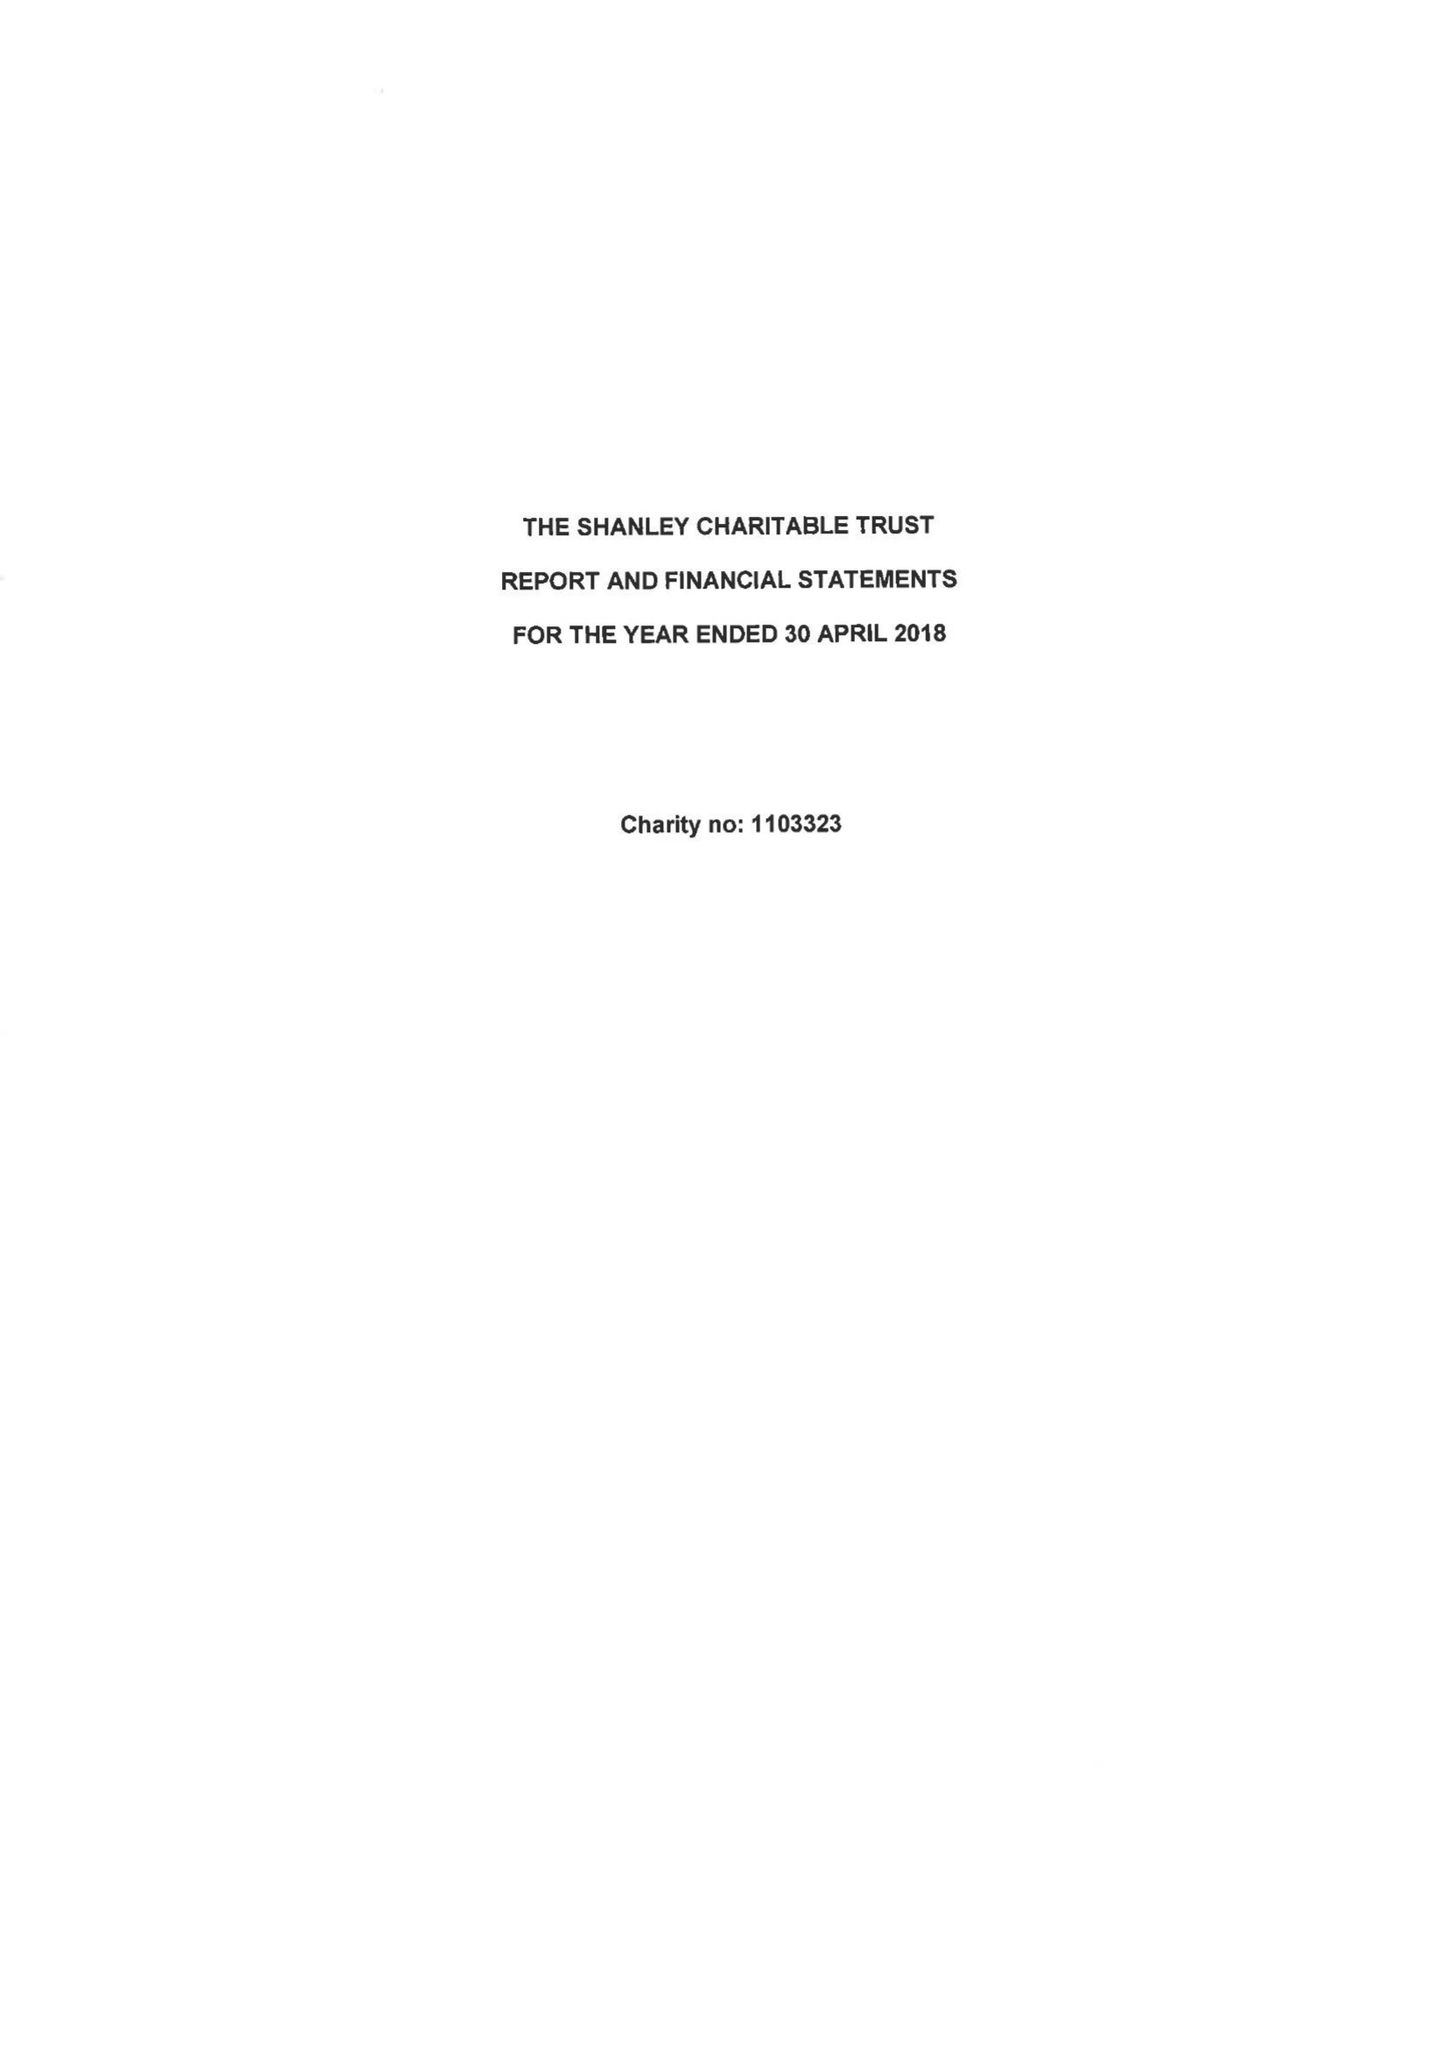What is the value for the income_annually_in_british_pounds?
Answer the question using a single word or phrase. 128380.00 